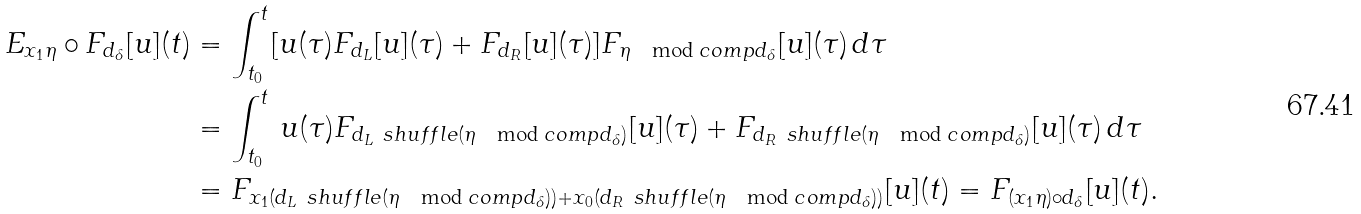Convert formula to latex. <formula><loc_0><loc_0><loc_500><loc_500>E _ { x _ { 1 } \eta } \circ F _ { d _ { \delta } } [ u ] ( t ) & = \int _ { t _ { 0 } } ^ { t } [ u ( \tau ) F _ { d _ { L } } [ u ] ( \tau ) + F _ { d _ { R } } [ u ] ( \tau ) ] F _ { \eta \mod c o m p d _ { \delta } } [ u ] ( \tau ) \, d \tau \\ & = \int _ { t _ { 0 } } ^ { t } \, u ( \tau ) F _ { d _ { L } \ s h u f f l e ( \eta \mod c o m p d _ { \delta } ) } [ u ] ( \tau ) + F _ { d _ { R } \ s h u f f l e ( \eta \mod c o m p d _ { \delta } ) } [ u ] ( \tau ) \, d \tau \\ & = F _ { x _ { 1 } ( d _ { L } \ s h u f f l e ( \eta \mod c o m p d _ { \delta } ) ) + x _ { 0 } ( d _ { R } \ s h u f f l e ( \eta \mod c o m p d _ { \delta } ) ) } [ u ] ( t ) = F _ { ( x _ { 1 } \eta ) \circ d _ { \delta } } [ u ] ( t ) .</formula> 